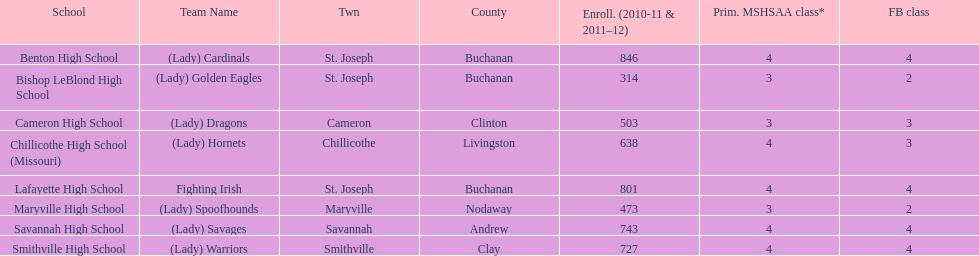How many schools are there in this conference? 8. 